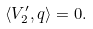<formula> <loc_0><loc_0><loc_500><loc_500>\langle V _ { 2 } ^ { \prime } , q \rangle = 0 .</formula> 